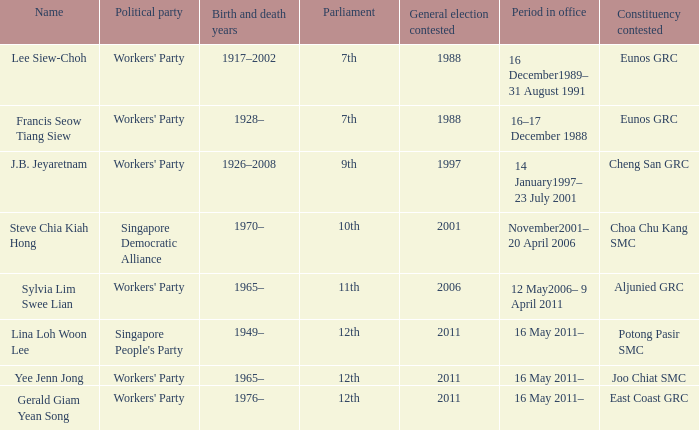Parse the table in full. {'header': ['Name', 'Political party', 'Birth and death years', 'Parliament', 'General election contested', 'Period in office', 'Constituency contested'], 'rows': [['Lee Siew-Choh', "Workers' Party", '1917–2002', '7th', '1988', '16 December1989– 31 August 1991', 'Eunos GRC'], ['Francis Seow Tiang Siew', "Workers' Party", '1928–', '7th', '1988', '16–17 December 1988', 'Eunos GRC'], ['J.B. Jeyaretnam', "Workers' Party", '1926–2008', '9th', '1997', '14 January1997– 23 July 2001', 'Cheng San GRC'], ['Steve Chia Kiah Hong', 'Singapore Democratic Alliance', '1970–', '10th', '2001', 'November2001– 20 April 2006', 'Choa Chu Kang SMC'], ['Sylvia Lim Swee Lian', "Workers' Party", '1965–', '11th', '2006', '12 May2006– 9 April 2011', 'Aljunied GRC'], ['Lina Loh Woon Lee', "Singapore People's Party", '1949–', '12th', '2011', '16 May 2011–', 'Potong Pasir SMC'], ['Yee Jenn Jong', "Workers' Party", '1965–', '12th', '2011', '16 May 2011–', 'Joo Chiat SMC'], ['Gerald Giam Yean Song', "Workers' Party", '1976–', '12th', '2011', '16 May 2011–', 'East Coast GRC']]} What number parliament held it's election in 1997? 9th. 